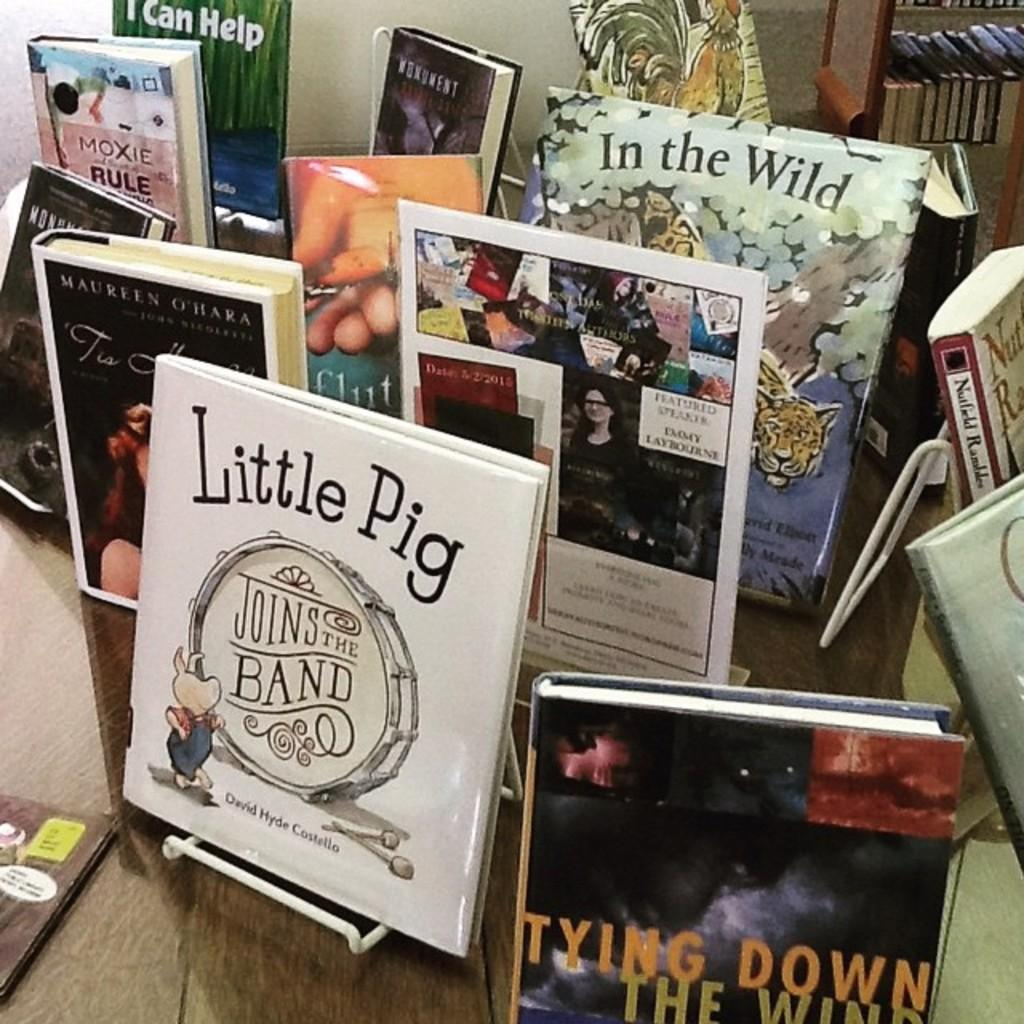<image>
Provide a brief description of the given image. the word tying is on the front of a book 